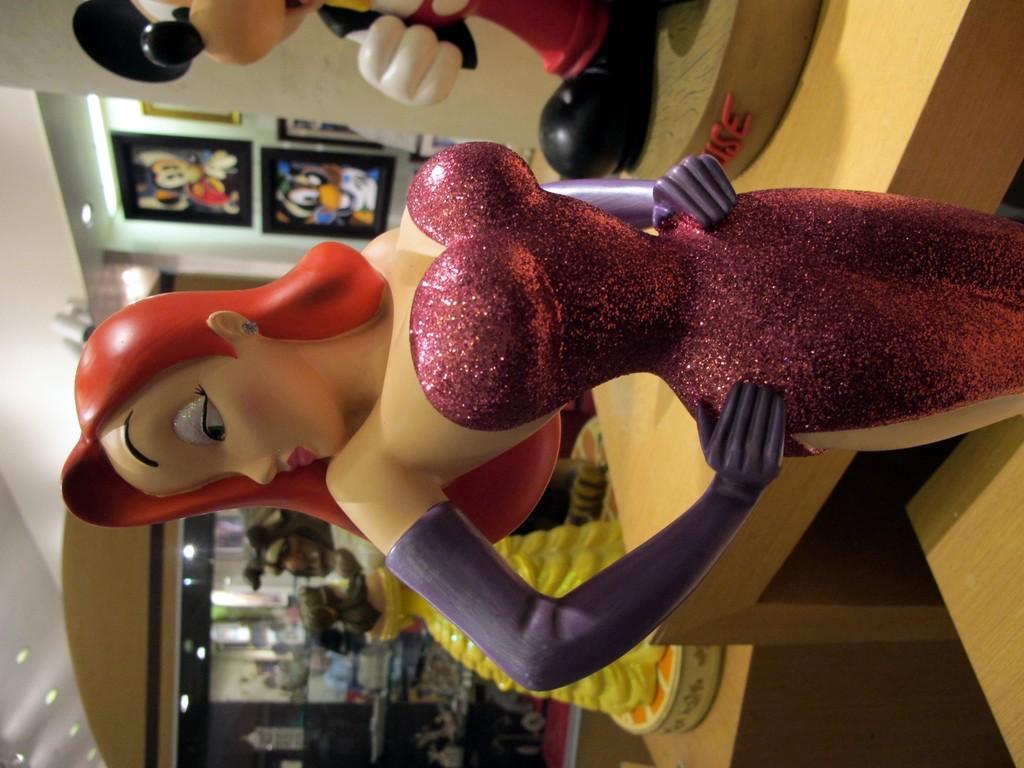In one or two sentences, can you explain what this image depicts? This image is a rotated image. In this image there is a doll, beside the doll there is a toy on the table, behind the doll there is an another toy on the other table. In the background there is a cupboard with some objects in it and on the other side of the wall there are a few frames hanging on the wall. At the top there is a ceiling with lights. 